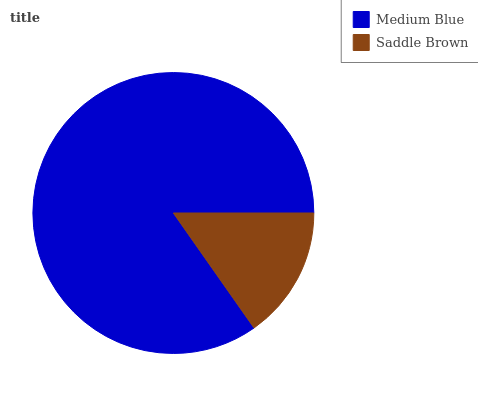Is Saddle Brown the minimum?
Answer yes or no. Yes. Is Medium Blue the maximum?
Answer yes or no. Yes. Is Saddle Brown the maximum?
Answer yes or no. No. Is Medium Blue greater than Saddle Brown?
Answer yes or no. Yes. Is Saddle Brown less than Medium Blue?
Answer yes or no. Yes. Is Saddle Brown greater than Medium Blue?
Answer yes or no. No. Is Medium Blue less than Saddle Brown?
Answer yes or no. No. Is Medium Blue the high median?
Answer yes or no. Yes. Is Saddle Brown the low median?
Answer yes or no. Yes. Is Saddle Brown the high median?
Answer yes or no. No. Is Medium Blue the low median?
Answer yes or no. No. 